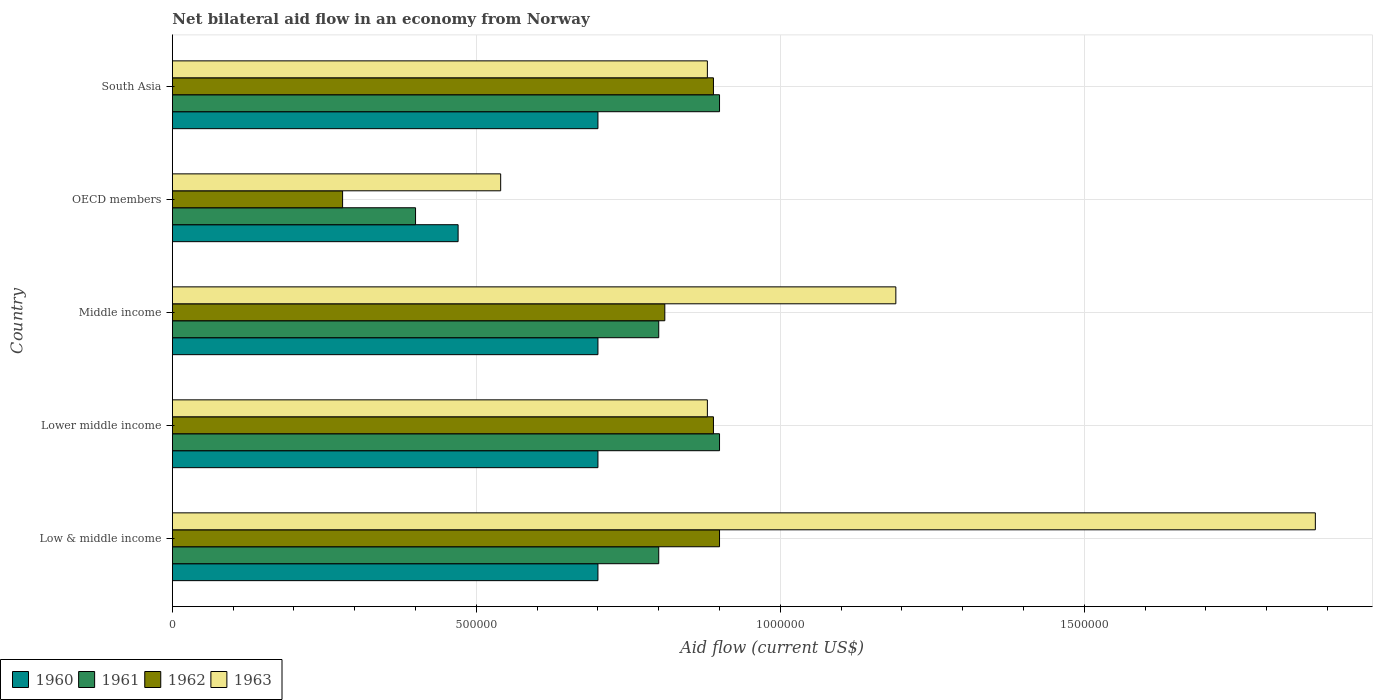How many different coloured bars are there?
Provide a short and direct response. 4. How many groups of bars are there?
Your response must be concise. 5. Are the number of bars per tick equal to the number of legend labels?
Give a very brief answer. Yes. Are the number of bars on each tick of the Y-axis equal?
Your answer should be compact. Yes. How many bars are there on the 1st tick from the top?
Provide a succinct answer. 4. In how many cases, is the number of bars for a given country not equal to the number of legend labels?
Provide a short and direct response. 0. What is the net bilateral aid flow in 1961 in Middle income?
Keep it short and to the point. 8.00e+05. Across all countries, what is the minimum net bilateral aid flow in 1963?
Make the answer very short. 5.40e+05. What is the total net bilateral aid flow in 1962 in the graph?
Your answer should be very brief. 3.77e+06. What is the difference between the net bilateral aid flow in 1962 in OECD members and the net bilateral aid flow in 1963 in Middle income?
Provide a succinct answer. -9.10e+05. What is the average net bilateral aid flow in 1961 per country?
Offer a terse response. 7.60e+05. What is the difference between the net bilateral aid flow in 1961 and net bilateral aid flow in 1962 in Middle income?
Offer a terse response. -10000. In how many countries, is the net bilateral aid flow in 1962 greater than 800000 US$?
Your answer should be very brief. 4. Is the difference between the net bilateral aid flow in 1961 in Lower middle income and Middle income greater than the difference between the net bilateral aid flow in 1962 in Lower middle income and Middle income?
Ensure brevity in your answer.  Yes. What is the difference between the highest and the second highest net bilateral aid flow in 1963?
Your answer should be compact. 6.90e+05. In how many countries, is the net bilateral aid flow in 1963 greater than the average net bilateral aid flow in 1963 taken over all countries?
Your answer should be compact. 2. Is the sum of the net bilateral aid flow in 1960 in OECD members and South Asia greater than the maximum net bilateral aid flow in 1963 across all countries?
Your response must be concise. No. What does the 2nd bar from the top in OECD members represents?
Your response must be concise. 1962. How many bars are there?
Make the answer very short. 20. How many countries are there in the graph?
Give a very brief answer. 5. Are the values on the major ticks of X-axis written in scientific E-notation?
Provide a short and direct response. No. Does the graph contain grids?
Your response must be concise. Yes. Where does the legend appear in the graph?
Provide a short and direct response. Bottom left. How many legend labels are there?
Make the answer very short. 4. How are the legend labels stacked?
Offer a terse response. Horizontal. What is the title of the graph?
Make the answer very short. Net bilateral aid flow in an economy from Norway. What is the label or title of the X-axis?
Your answer should be compact. Aid flow (current US$). What is the Aid flow (current US$) of 1960 in Low & middle income?
Make the answer very short. 7.00e+05. What is the Aid flow (current US$) of 1962 in Low & middle income?
Ensure brevity in your answer.  9.00e+05. What is the Aid flow (current US$) in 1963 in Low & middle income?
Offer a very short reply. 1.88e+06. What is the Aid flow (current US$) in 1961 in Lower middle income?
Your response must be concise. 9.00e+05. What is the Aid flow (current US$) of 1962 in Lower middle income?
Provide a short and direct response. 8.90e+05. What is the Aid flow (current US$) in 1963 in Lower middle income?
Ensure brevity in your answer.  8.80e+05. What is the Aid flow (current US$) of 1961 in Middle income?
Keep it short and to the point. 8.00e+05. What is the Aid flow (current US$) in 1962 in Middle income?
Ensure brevity in your answer.  8.10e+05. What is the Aid flow (current US$) in 1963 in Middle income?
Your answer should be compact. 1.19e+06. What is the Aid flow (current US$) in 1960 in OECD members?
Your answer should be compact. 4.70e+05. What is the Aid flow (current US$) of 1962 in OECD members?
Your answer should be compact. 2.80e+05. What is the Aid flow (current US$) of 1963 in OECD members?
Your response must be concise. 5.40e+05. What is the Aid flow (current US$) of 1961 in South Asia?
Offer a very short reply. 9.00e+05. What is the Aid flow (current US$) in 1962 in South Asia?
Your answer should be compact. 8.90e+05. What is the Aid flow (current US$) of 1963 in South Asia?
Your answer should be compact. 8.80e+05. Across all countries, what is the maximum Aid flow (current US$) of 1960?
Provide a short and direct response. 7.00e+05. Across all countries, what is the maximum Aid flow (current US$) in 1961?
Make the answer very short. 9.00e+05. Across all countries, what is the maximum Aid flow (current US$) of 1962?
Give a very brief answer. 9.00e+05. Across all countries, what is the maximum Aid flow (current US$) of 1963?
Your answer should be very brief. 1.88e+06. Across all countries, what is the minimum Aid flow (current US$) in 1960?
Provide a succinct answer. 4.70e+05. Across all countries, what is the minimum Aid flow (current US$) of 1963?
Ensure brevity in your answer.  5.40e+05. What is the total Aid flow (current US$) of 1960 in the graph?
Give a very brief answer. 3.27e+06. What is the total Aid flow (current US$) of 1961 in the graph?
Your response must be concise. 3.80e+06. What is the total Aid flow (current US$) of 1962 in the graph?
Offer a terse response. 3.77e+06. What is the total Aid flow (current US$) of 1963 in the graph?
Your answer should be compact. 5.37e+06. What is the difference between the Aid flow (current US$) in 1960 in Low & middle income and that in Lower middle income?
Give a very brief answer. 0. What is the difference between the Aid flow (current US$) of 1963 in Low & middle income and that in Lower middle income?
Your answer should be very brief. 1.00e+06. What is the difference between the Aid flow (current US$) of 1961 in Low & middle income and that in Middle income?
Your answer should be very brief. 0. What is the difference between the Aid flow (current US$) of 1963 in Low & middle income and that in Middle income?
Offer a very short reply. 6.90e+05. What is the difference between the Aid flow (current US$) of 1962 in Low & middle income and that in OECD members?
Make the answer very short. 6.20e+05. What is the difference between the Aid flow (current US$) in 1963 in Low & middle income and that in OECD members?
Provide a succinct answer. 1.34e+06. What is the difference between the Aid flow (current US$) in 1960 in Low & middle income and that in South Asia?
Provide a short and direct response. 0. What is the difference between the Aid flow (current US$) in 1961 in Lower middle income and that in Middle income?
Your answer should be compact. 1.00e+05. What is the difference between the Aid flow (current US$) in 1963 in Lower middle income and that in Middle income?
Provide a short and direct response. -3.10e+05. What is the difference between the Aid flow (current US$) of 1961 in Lower middle income and that in OECD members?
Your response must be concise. 5.00e+05. What is the difference between the Aid flow (current US$) in 1963 in Lower middle income and that in OECD members?
Offer a very short reply. 3.40e+05. What is the difference between the Aid flow (current US$) of 1961 in Lower middle income and that in South Asia?
Your answer should be very brief. 0. What is the difference between the Aid flow (current US$) in 1963 in Lower middle income and that in South Asia?
Your answer should be very brief. 0. What is the difference between the Aid flow (current US$) of 1960 in Middle income and that in OECD members?
Your answer should be very brief. 2.30e+05. What is the difference between the Aid flow (current US$) of 1962 in Middle income and that in OECD members?
Your answer should be very brief. 5.30e+05. What is the difference between the Aid flow (current US$) of 1963 in Middle income and that in OECD members?
Offer a very short reply. 6.50e+05. What is the difference between the Aid flow (current US$) in 1962 in Middle income and that in South Asia?
Keep it short and to the point. -8.00e+04. What is the difference between the Aid flow (current US$) in 1963 in Middle income and that in South Asia?
Offer a terse response. 3.10e+05. What is the difference between the Aid flow (current US$) in 1960 in OECD members and that in South Asia?
Ensure brevity in your answer.  -2.30e+05. What is the difference between the Aid flow (current US$) of 1961 in OECD members and that in South Asia?
Your answer should be compact. -5.00e+05. What is the difference between the Aid flow (current US$) in 1962 in OECD members and that in South Asia?
Provide a short and direct response. -6.10e+05. What is the difference between the Aid flow (current US$) in 1960 in Low & middle income and the Aid flow (current US$) in 1962 in Lower middle income?
Your answer should be very brief. -1.90e+05. What is the difference between the Aid flow (current US$) in 1960 in Low & middle income and the Aid flow (current US$) in 1963 in Lower middle income?
Offer a very short reply. -1.80e+05. What is the difference between the Aid flow (current US$) of 1961 in Low & middle income and the Aid flow (current US$) of 1963 in Lower middle income?
Offer a terse response. -8.00e+04. What is the difference between the Aid flow (current US$) of 1962 in Low & middle income and the Aid flow (current US$) of 1963 in Lower middle income?
Keep it short and to the point. 2.00e+04. What is the difference between the Aid flow (current US$) in 1960 in Low & middle income and the Aid flow (current US$) in 1962 in Middle income?
Your response must be concise. -1.10e+05. What is the difference between the Aid flow (current US$) in 1960 in Low & middle income and the Aid flow (current US$) in 1963 in Middle income?
Ensure brevity in your answer.  -4.90e+05. What is the difference between the Aid flow (current US$) in 1961 in Low & middle income and the Aid flow (current US$) in 1963 in Middle income?
Ensure brevity in your answer.  -3.90e+05. What is the difference between the Aid flow (current US$) in 1962 in Low & middle income and the Aid flow (current US$) in 1963 in Middle income?
Offer a terse response. -2.90e+05. What is the difference between the Aid flow (current US$) in 1961 in Low & middle income and the Aid flow (current US$) in 1962 in OECD members?
Ensure brevity in your answer.  5.20e+05. What is the difference between the Aid flow (current US$) of 1962 in Low & middle income and the Aid flow (current US$) of 1963 in OECD members?
Ensure brevity in your answer.  3.60e+05. What is the difference between the Aid flow (current US$) of 1960 in Low & middle income and the Aid flow (current US$) of 1961 in South Asia?
Your response must be concise. -2.00e+05. What is the difference between the Aid flow (current US$) in 1960 in Low & middle income and the Aid flow (current US$) in 1963 in South Asia?
Ensure brevity in your answer.  -1.80e+05. What is the difference between the Aid flow (current US$) in 1961 in Low & middle income and the Aid flow (current US$) in 1962 in South Asia?
Your answer should be very brief. -9.00e+04. What is the difference between the Aid flow (current US$) in 1962 in Low & middle income and the Aid flow (current US$) in 1963 in South Asia?
Keep it short and to the point. 2.00e+04. What is the difference between the Aid flow (current US$) of 1960 in Lower middle income and the Aid flow (current US$) of 1961 in Middle income?
Your answer should be compact. -1.00e+05. What is the difference between the Aid flow (current US$) in 1960 in Lower middle income and the Aid flow (current US$) in 1963 in Middle income?
Offer a very short reply. -4.90e+05. What is the difference between the Aid flow (current US$) of 1961 in Lower middle income and the Aid flow (current US$) of 1963 in Middle income?
Your answer should be very brief. -2.90e+05. What is the difference between the Aid flow (current US$) in 1960 in Lower middle income and the Aid flow (current US$) in 1961 in OECD members?
Offer a terse response. 3.00e+05. What is the difference between the Aid flow (current US$) in 1960 in Lower middle income and the Aid flow (current US$) in 1963 in OECD members?
Offer a terse response. 1.60e+05. What is the difference between the Aid flow (current US$) in 1961 in Lower middle income and the Aid flow (current US$) in 1962 in OECD members?
Keep it short and to the point. 6.20e+05. What is the difference between the Aid flow (current US$) in 1960 in Lower middle income and the Aid flow (current US$) in 1961 in South Asia?
Keep it short and to the point. -2.00e+05. What is the difference between the Aid flow (current US$) in 1960 in Lower middle income and the Aid flow (current US$) in 1962 in South Asia?
Provide a succinct answer. -1.90e+05. What is the difference between the Aid flow (current US$) in 1960 in Lower middle income and the Aid flow (current US$) in 1963 in South Asia?
Your response must be concise. -1.80e+05. What is the difference between the Aid flow (current US$) of 1961 in Lower middle income and the Aid flow (current US$) of 1962 in South Asia?
Provide a succinct answer. 10000. What is the difference between the Aid flow (current US$) in 1961 in Lower middle income and the Aid flow (current US$) in 1963 in South Asia?
Provide a short and direct response. 2.00e+04. What is the difference between the Aid flow (current US$) in 1960 in Middle income and the Aid flow (current US$) in 1963 in OECD members?
Provide a succinct answer. 1.60e+05. What is the difference between the Aid flow (current US$) in 1961 in Middle income and the Aid flow (current US$) in 1962 in OECD members?
Your answer should be very brief. 5.20e+05. What is the difference between the Aid flow (current US$) in 1960 in Middle income and the Aid flow (current US$) in 1962 in South Asia?
Your answer should be very brief. -1.90e+05. What is the difference between the Aid flow (current US$) of 1960 in Middle income and the Aid flow (current US$) of 1963 in South Asia?
Keep it short and to the point. -1.80e+05. What is the difference between the Aid flow (current US$) of 1961 in Middle income and the Aid flow (current US$) of 1962 in South Asia?
Provide a short and direct response. -9.00e+04. What is the difference between the Aid flow (current US$) of 1960 in OECD members and the Aid flow (current US$) of 1961 in South Asia?
Your response must be concise. -4.30e+05. What is the difference between the Aid flow (current US$) in 1960 in OECD members and the Aid flow (current US$) in 1962 in South Asia?
Your answer should be compact. -4.20e+05. What is the difference between the Aid flow (current US$) of 1960 in OECD members and the Aid flow (current US$) of 1963 in South Asia?
Offer a terse response. -4.10e+05. What is the difference between the Aid flow (current US$) in 1961 in OECD members and the Aid flow (current US$) in 1962 in South Asia?
Offer a terse response. -4.90e+05. What is the difference between the Aid flow (current US$) in 1961 in OECD members and the Aid flow (current US$) in 1963 in South Asia?
Offer a very short reply. -4.80e+05. What is the difference between the Aid flow (current US$) of 1962 in OECD members and the Aid flow (current US$) of 1963 in South Asia?
Give a very brief answer. -6.00e+05. What is the average Aid flow (current US$) in 1960 per country?
Provide a short and direct response. 6.54e+05. What is the average Aid flow (current US$) in 1961 per country?
Provide a succinct answer. 7.60e+05. What is the average Aid flow (current US$) of 1962 per country?
Make the answer very short. 7.54e+05. What is the average Aid flow (current US$) of 1963 per country?
Offer a terse response. 1.07e+06. What is the difference between the Aid flow (current US$) of 1960 and Aid flow (current US$) of 1961 in Low & middle income?
Your answer should be very brief. -1.00e+05. What is the difference between the Aid flow (current US$) in 1960 and Aid flow (current US$) in 1963 in Low & middle income?
Offer a terse response. -1.18e+06. What is the difference between the Aid flow (current US$) in 1961 and Aid flow (current US$) in 1963 in Low & middle income?
Your answer should be very brief. -1.08e+06. What is the difference between the Aid flow (current US$) of 1962 and Aid flow (current US$) of 1963 in Low & middle income?
Provide a succinct answer. -9.80e+05. What is the difference between the Aid flow (current US$) of 1960 and Aid flow (current US$) of 1962 in Lower middle income?
Offer a very short reply. -1.90e+05. What is the difference between the Aid flow (current US$) in 1960 and Aid flow (current US$) in 1963 in Middle income?
Provide a succinct answer. -4.90e+05. What is the difference between the Aid flow (current US$) of 1961 and Aid flow (current US$) of 1962 in Middle income?
Ensure brevity in your answer.  -10000. What is the difference between the Aid flow (current US$) in 1961 and Aid flow (current US$) in 1963 in Middle income?
Provide a succinct answer. -3.90e+05. What is the difference between the Aid flow (current US$) of 1962 and Aid flow (current US$) of 1963 in Middle income?
Provide a succinct answer. -3.80e+05. What is the difference between the Aid flow (current US$) of 1960 and Aid flow (current US$) of 1962 in OECD members?
Offer a very short reply. 1.90e+05. What is the difference between the Aid flow (current US$) in 1961 and Aid flow (current US$) in 1963 in OECD members?
Your answer should be compact. -1.40e+05. What is the difference between the Aid flow (current US$) in 1960 and Aid flow (current US$) in 1961 in South Asia?
Your answer should be compact. -2.00e+05. What is the difference between the Aid flow (current US$) of 1961 and Aid flow (current US$) of 1962 in South Asia?
Offer a terse response. 10000. What is the difference between the Aid flow (current US$) in 1962 and Aid flow (current US$) in 1963 in South Asia?
Make the answer very short. 10000. What is the ratio of the Aid flow (current US$) in 1960 in Low & middle income to that in Lower middle income?
Make the answer very short. 1. What is the ratio of the Aid flow (current US$) of 1961 in Low & middle income to that in Lower middle income?
Make the answer very short. 0.89. What is the ratio of the Aid flow (current US$) of 1962 in Low & middle income to that in Lower middle income?
Provide a succinct answer. 1.01. What is the ratio of the Aid flow (current US$) of 1963 in Low & middle income to that in Lower middle income?
Your answer should be very brief. 2.14. What is the ratio of the Aid flow (current US$) of 1960 in Low & middle income to that in Middle income?
Offer a terse response. 1. What is the ratio of the Aid flow (current US$) of 1962 in Low & middle income to that in Middle income?
Keep it short and to the point. 1.11. What is the ratio of the Aid flow (current US$) of 1963 in Low & middle income to that in Middle income?
Provide a short and direct response. 1.58. What is the ratio of the Aid flow (current US$) in 1960 in Low & middle income to that in OECD members?
Offer a very short reply. 1.49. What is the ratio of the Aid flow (current US$) in 1962 in Low & middle income to that in OECD members?
Offer a terse response. 3.21. What is the ratio of the Aid flow (current US$) of 1963 in Low & middle income to that in OECD members?
Offer a terse response. 3.48. What is the ratio of the Aid flow (current US$) of 1962 in Low & middle income to that in South Asia?
Your answer should be compact. 1.01. What is the ratio of the Aid flow (current US$) of 1963 in Low & middle income to that in South Asia?
Your response must be concise. 2.14. What is the ratio of the Aid flow (current US$) of 1962 in Lower middle income to that in Middle income?
Your answer should be very brief. 1.1. What is the ratio of the Aid flow (current US$) in 1963 in Lower middle income to that in Middle income?
Offer a terse response. 0.74. What is the ratio of the Aid flow (current US$) of 1960 in Lower middle income to that in OECD members?
Keep it short and to the point. 1.49. What is the ratio of the Aid flow (current US$) in 1961 in Lower middle income to that in OECD members?
Ensure brevity in your answer.  2.25. What is the ratio of the Aid flow (current US$) in 1962 in Lower middle income to that in OECD members?
Your answer should be compact. 3.18. What is the ratio of the Aid flow (current US$) of 1963 in Lower middle income to that in OECD members?
Your answer should be compact. 1.63. What is the ratio of the Aid flow (current US$) in 1962 in Lower middle income to that in South Asia?
Your answer should be compact. 1. What is the ratio of the Aid flow (current US$) of 1963 in Lower middle income to that in South Asia?
Provide a short and direct response. 1. What is the ratio of the Aid flow (current US$) in 1960 in Middle income to that in OECD members?
Offer a very short reply. 1.49. What is the ratio of the Aid flow (current US$) of 1961 in Middle income to that in OECD members?
Offer a very short reply. 2. What is the ratio of the Aid flow (current US$) in 1962 in Middle income to that in OECD members?
Offer a very short reply. 2.89. What is the ratio of the Aid flow (current US$) of 1963 in Middle income to that in OECD members?
Give a very brief answer. 2.2. What is the ratio of the Aid flow (current US$) of 1961 in Middle income to that in South Asia?
Provide a short and direct response. 0.89. What is the ratio of the Aid flow (current US$) in 1962 in Middle income to that in South Asia?
Give a very brief answer. 0.91. What is the ratio of the Aid flow (current US$) of 1963 in Middle income to that in South Asia?
Provide a short and direct response. 1.35. What is the ratio of the Aid flow (current US$) of 1960 in OECD members to that in South Asia?
Offer a terse response. 0.67. What is the ratio of the Aid flow (current US$) of 1961 in OECD members to that in South Asia?
Provide a succinct answer. 0.44. What is the ratio of the Aid flow (current US$) of 1962 in OECD members to that in South Asia?
Make the answer very short. 0.31. What is the ratio of the Aid flow (current US$) of 1963 in OECD members to that in South Asia?
Provide a short and direct response. 0.61. What is the difference between the highest and the second highest Aid flow (current US$) of 1960?
Provide a short and direct response. 0. What is the difference between the highest and the second highest Aid flow (current US$) in 1961?
Offer a terse response. 0. What is the difference between the highest and the second highest Aid flow (current US$) of 1962?
Keep it short and to the point. 10000. What is the difference between the highest and the second highest Aid flow (current US$) of 1963?
Your answer should be very brief. 6.90e+05. What is the difference between the highest and the lowest Aid flow (current US$) in 1962?
Your answer should be compact. 6.20e+05. What is the difference between the highest and the lowest Aid flow (current US$) in 1963?
Ensure brevity in your answer.  1.34e+06. 